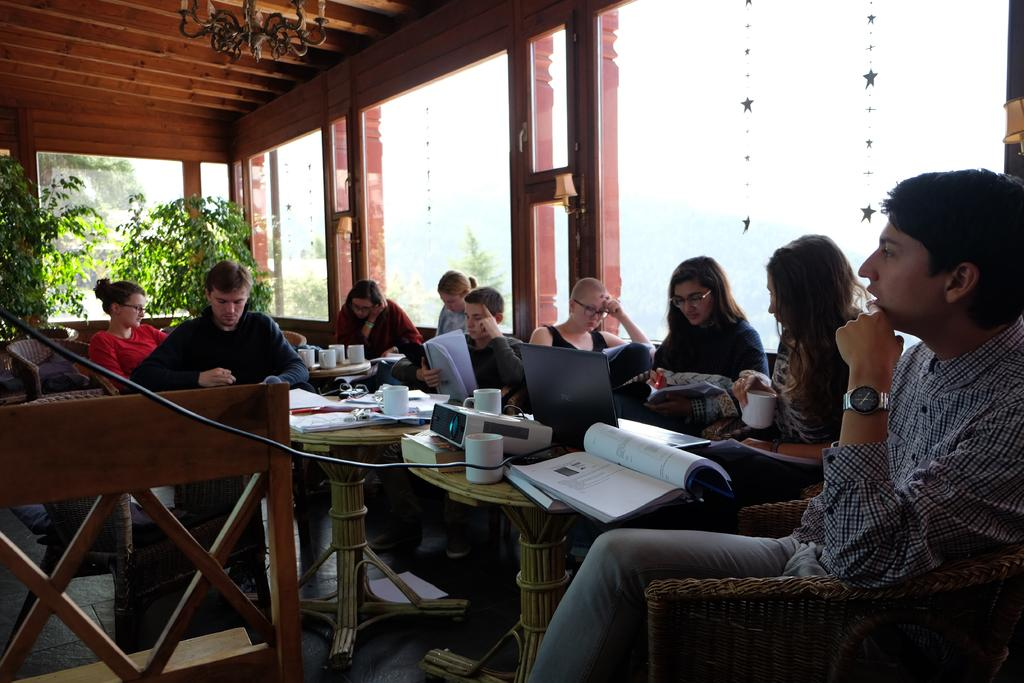What is happening in the image involving a group of people? There is a group of people in the image, and they are seated on chairs. What are some of the people doing in the image? Some people are reading books in the image. Can you describe the woman in the image? The woman in the image is holding a cup in her hand. What object related to presentations can be seen in the image? There is a projector in the image. Where are the cups located in the image? The cups are on a table in the image. What type of toothbrush is being used by the people in the image? There is no toothbrush present in the image; the people are seated and reading books or holding cups. 